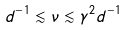Convert formula to latex. <formula><loc_0><loc_0><loc_500><loc_500>d ^ { - 1 } \lesssim \nu \lesssim \gamma ^ { 2 } d ^ { - 1 }</formula> 